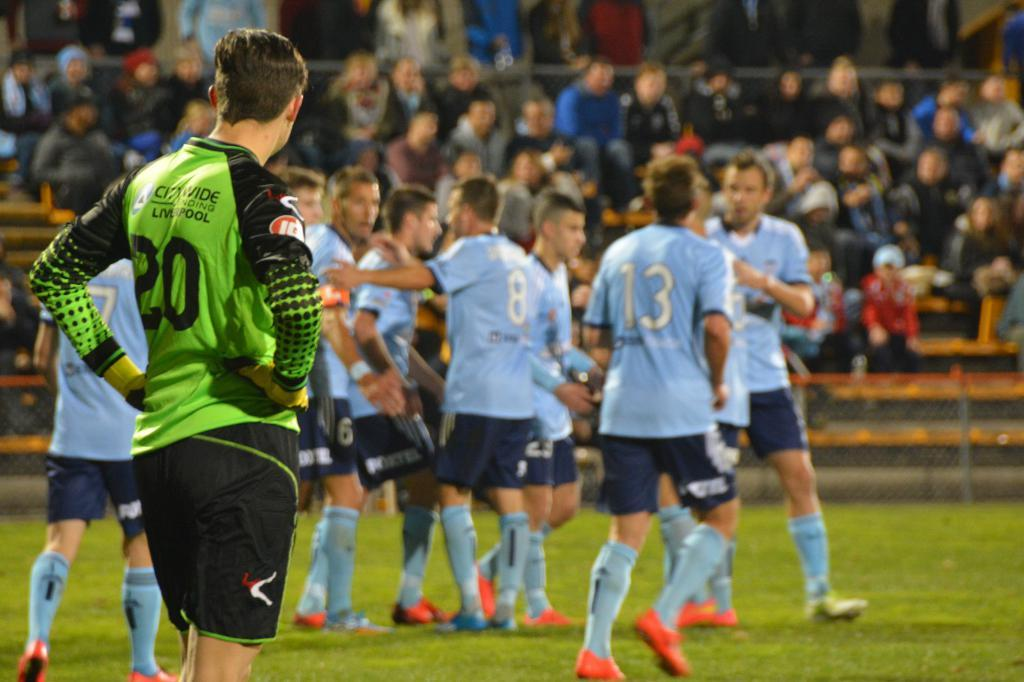<image>
Summarize the visual content of the image. numerous soccer players wearing blue jerseys stand in a group while number 13 runs towards them. 